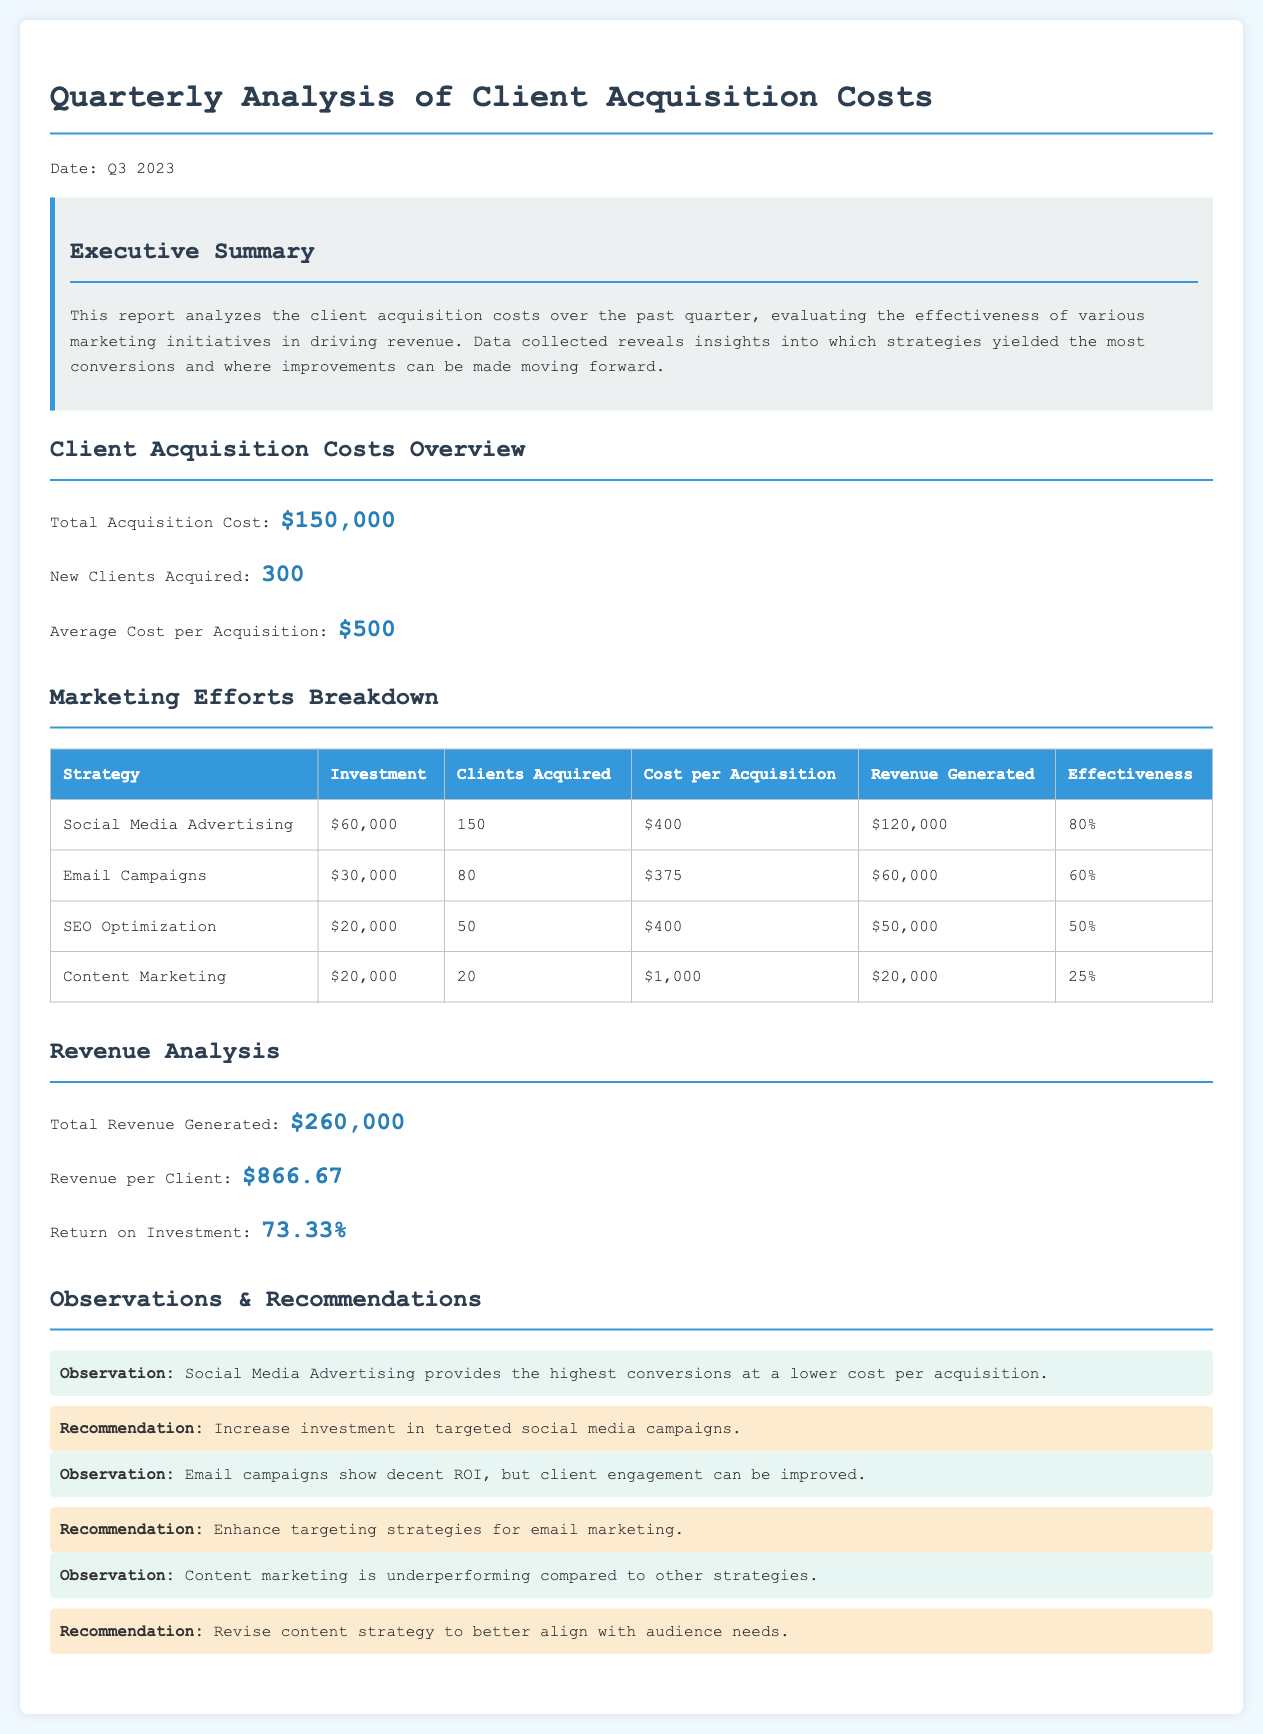What is the total acquisition cost? The total acquisition cost is stated in the document as $150,000.
Answer: $150,000 How many new clients were acquired? The number of new clients acquired is mentioned in the overview section as 300.
Answer: 300 What strategy had the highest effectiveness percentage? The effectiveness percentage for each strategy is provided in the marketing efforts breakdown; Social Media Advertising has the highest at 80%.
Answer: 80% What is the cost per acquisition for Email Campaigns? The cost per acquisition for Email Campaigns is detailed in the marketing efforts table as $375.
Answer: $375 What recommendation was made regarding content marketing? The recommendation for content marketing is to revise the content strategy to better align with audience needs.
Answer: Revise content strategy What is the total revenue generated during the quarter? The total revenue generated is calculated in the revenue analysis section and stated as $260,000.
Answer: $260,000 What is the average cost per acquisition? The average cost per acquisition is indicated in the overview section as $500.
Answer: $500 Which marketing strategy generated the least revenue? By comparing the revenue generated for each strategy, Content Marketing shows the least revenue at $20,000.
Answer: $20,000 What is the return on investment percentage? The return on investment is calculated in the revenue analysis section and is stated as 73.33%.
Answer: 73.33% 